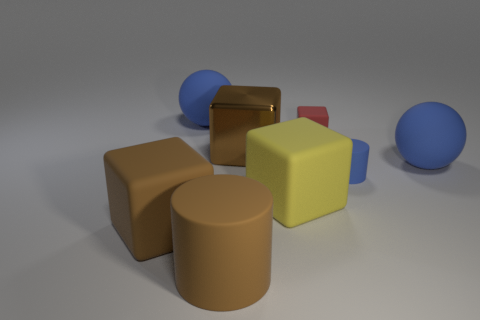Subtract all metallic blocks. How many blocks are left? 3 Add 4 big yellow things. How many big yellow things exist? 5 Add 1 tiny red metallic objects. How many objects exist? 9 Subtract all red cubes. How many cubes are left? 3 Subtract 0 yellow cylinders. How many objects are left? 8 Subtract all balls. How many objects are left? 6 Subtract 3 blocks. How many blocks are left? 1 Subtract all cyan cubes. Subtract all purple spheres. How many cubes are left? 4 Subtract all red cylinders. How many red cubes are left? 1 Subtract all big purple metallic cylinders. Subtract all cylinders. How many objects are left? 6 